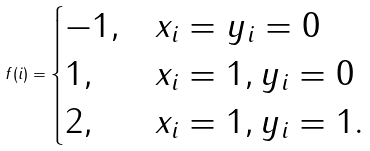Convert formula to latex. <formula><loc_0><loc_0><loc_500><loc_500>f ( i ) = \begin{cases} - 1 , & x _ { i } = y _ { i } = 0 \\ 1 , & x _ { i } = 1 , y _ { i } = 0 \\ 2 , & x _ { i } = 1 , y _ { i } = 1 . \end{cases}</formula> 